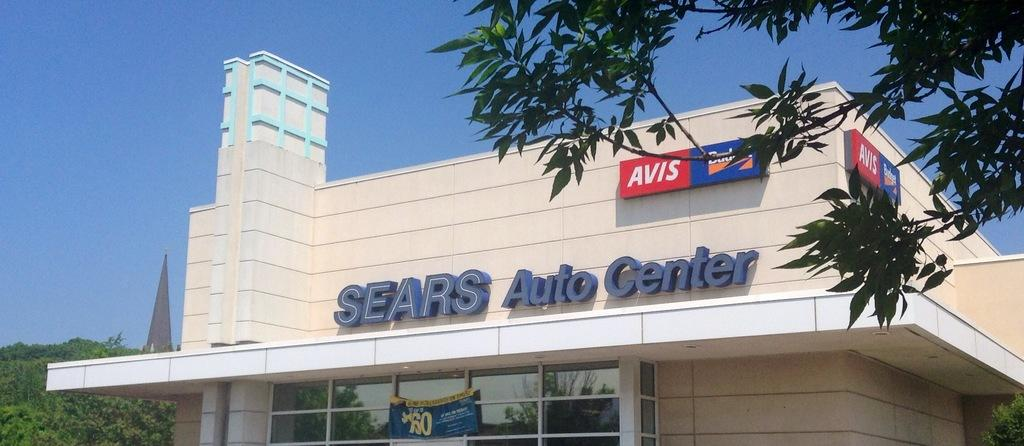<image>
Give a short and clear explanation of the subsequent image. A Sears Auto Center store is on the corner of a street. 